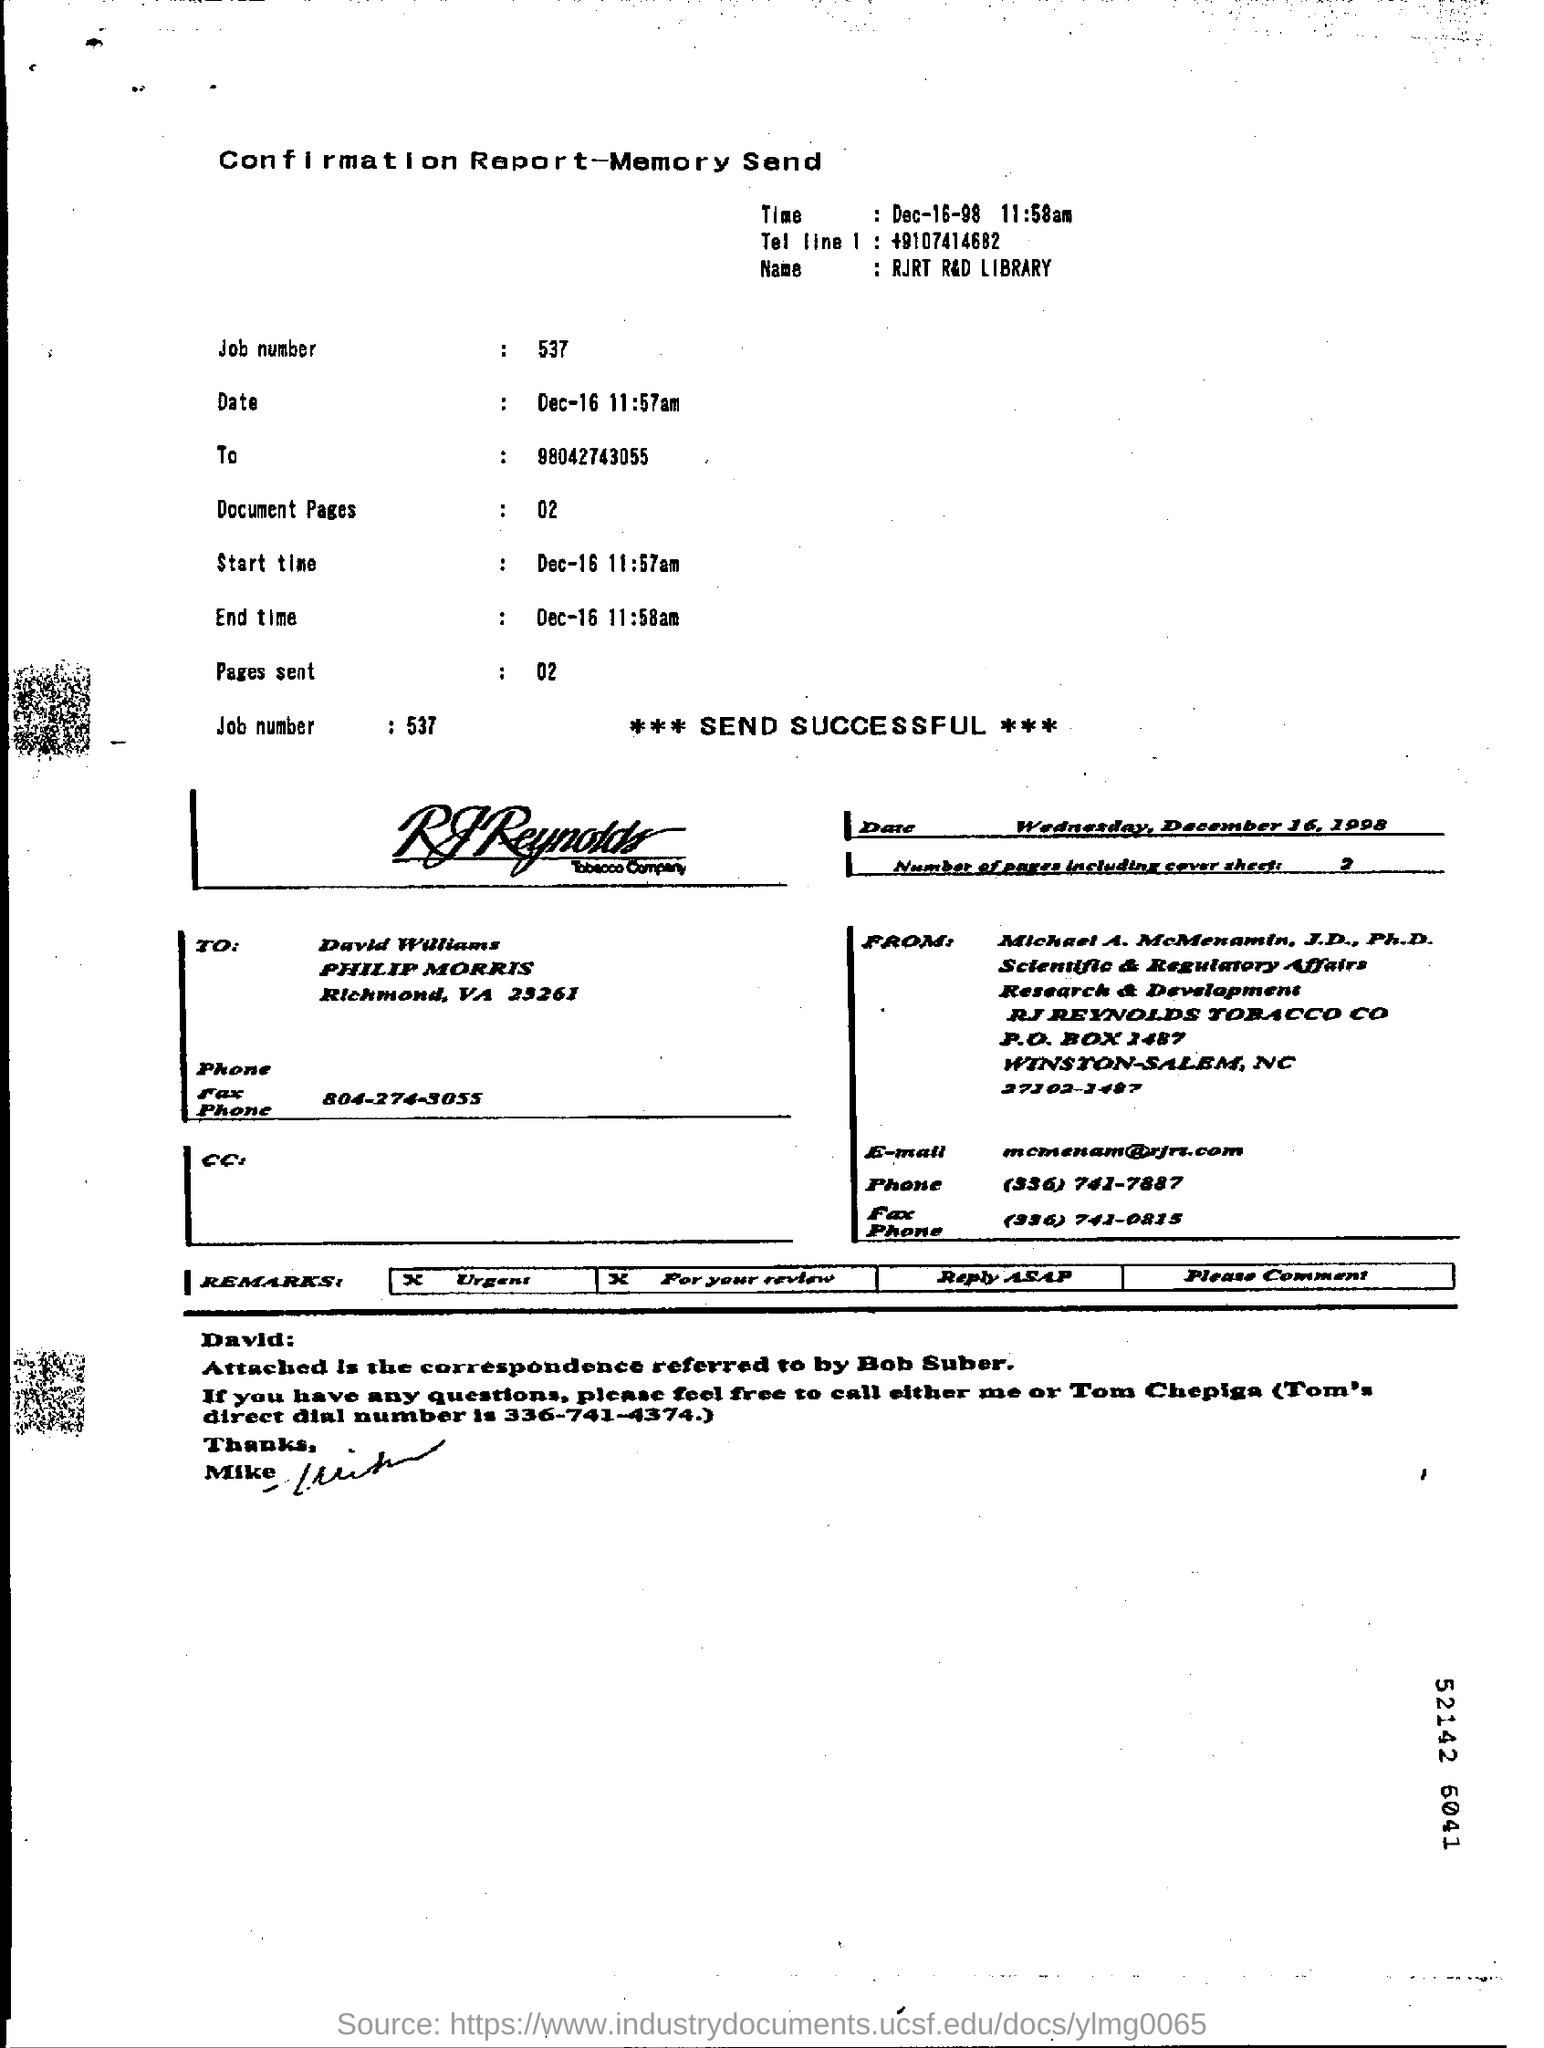What day was on December 16, 1998?
Your answer should be compact. Wednesday. 